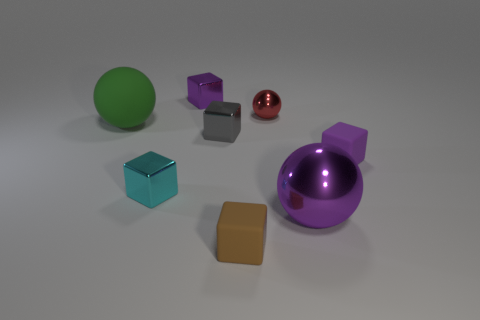What shape is the purple shiny thing behind the tiny purple object that is to the right of the small gray metal block?
Offer a very short reply. Cube. Is there a gray object of the same shape as the brown matte object?
Offer a terse response. Yes. There is a brown object that is the same size as the gray metal block; what shape is it?
Ensure brevity in your answer.  Cube. There is a small rubber cube in front of the small purple block that is on the right side of the small brown block; are there any tiny metal objects right of it?
Make the answer very short. Yes. Are there any metal blocks of the same size as the cyan thing?
Provide a succinct answer. Yes. What size is the purple metal object that is in front of the cyan metal block?
Offer a terse response. Large. What is the color of the small shiny thing that is right of the tiny matte block to the left of the large sphere in front of the cyan metal block?
Make the answer very short. Red. What is the color of the tiny metal block to the left of the tiny purple thing that is left of the tiny brown rubber block?
Provide a succinct answer. Cyan. Are there more large matte objects that are left of the small shiny ball than shiny cubes that are behind the small cyan block?
Ensure brevity in your answer.  No. Is the purple cube on the right side of the brown cube made of the same material as the large object in front of the green object?
Keep it short and to the point. No. 